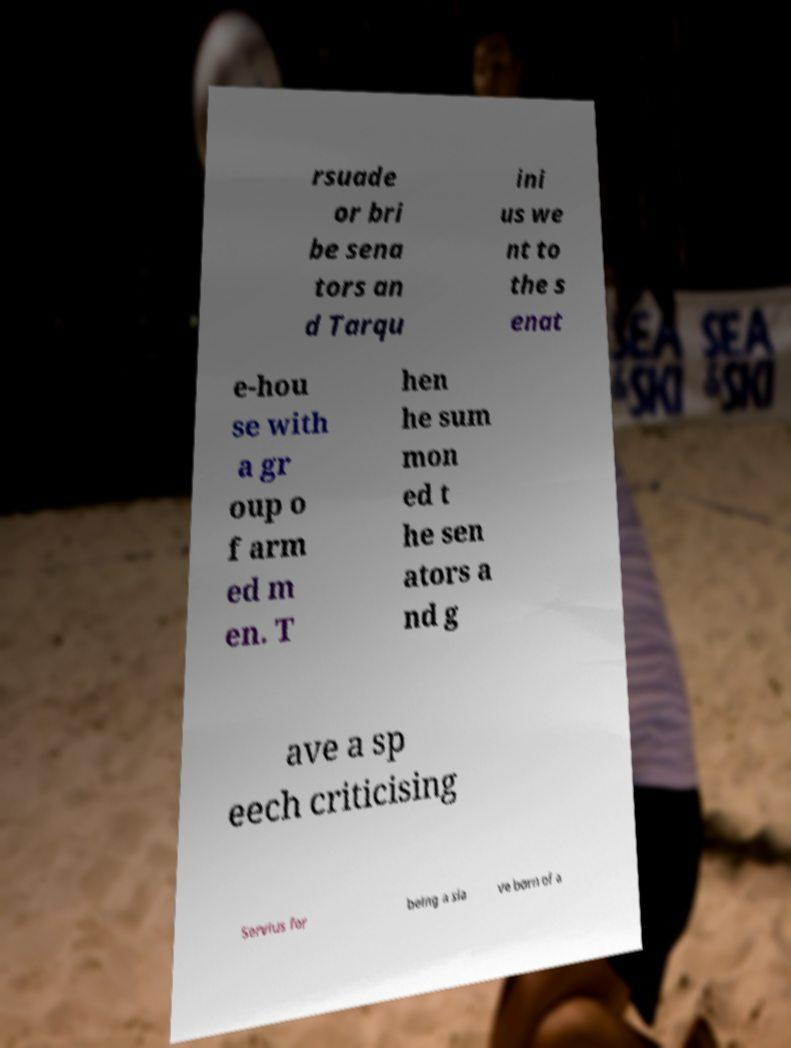Can you accurately transcribe the text from the provided image for me? rsuade or bri be sena tors an d Tarqu ini us we nt to the s enat e-hou se with a gr oup o f arm ed m en. T hen he sum mon ed t he sen ators a nd g ave a sp eech criticising Servius for being a sla ve born of a 